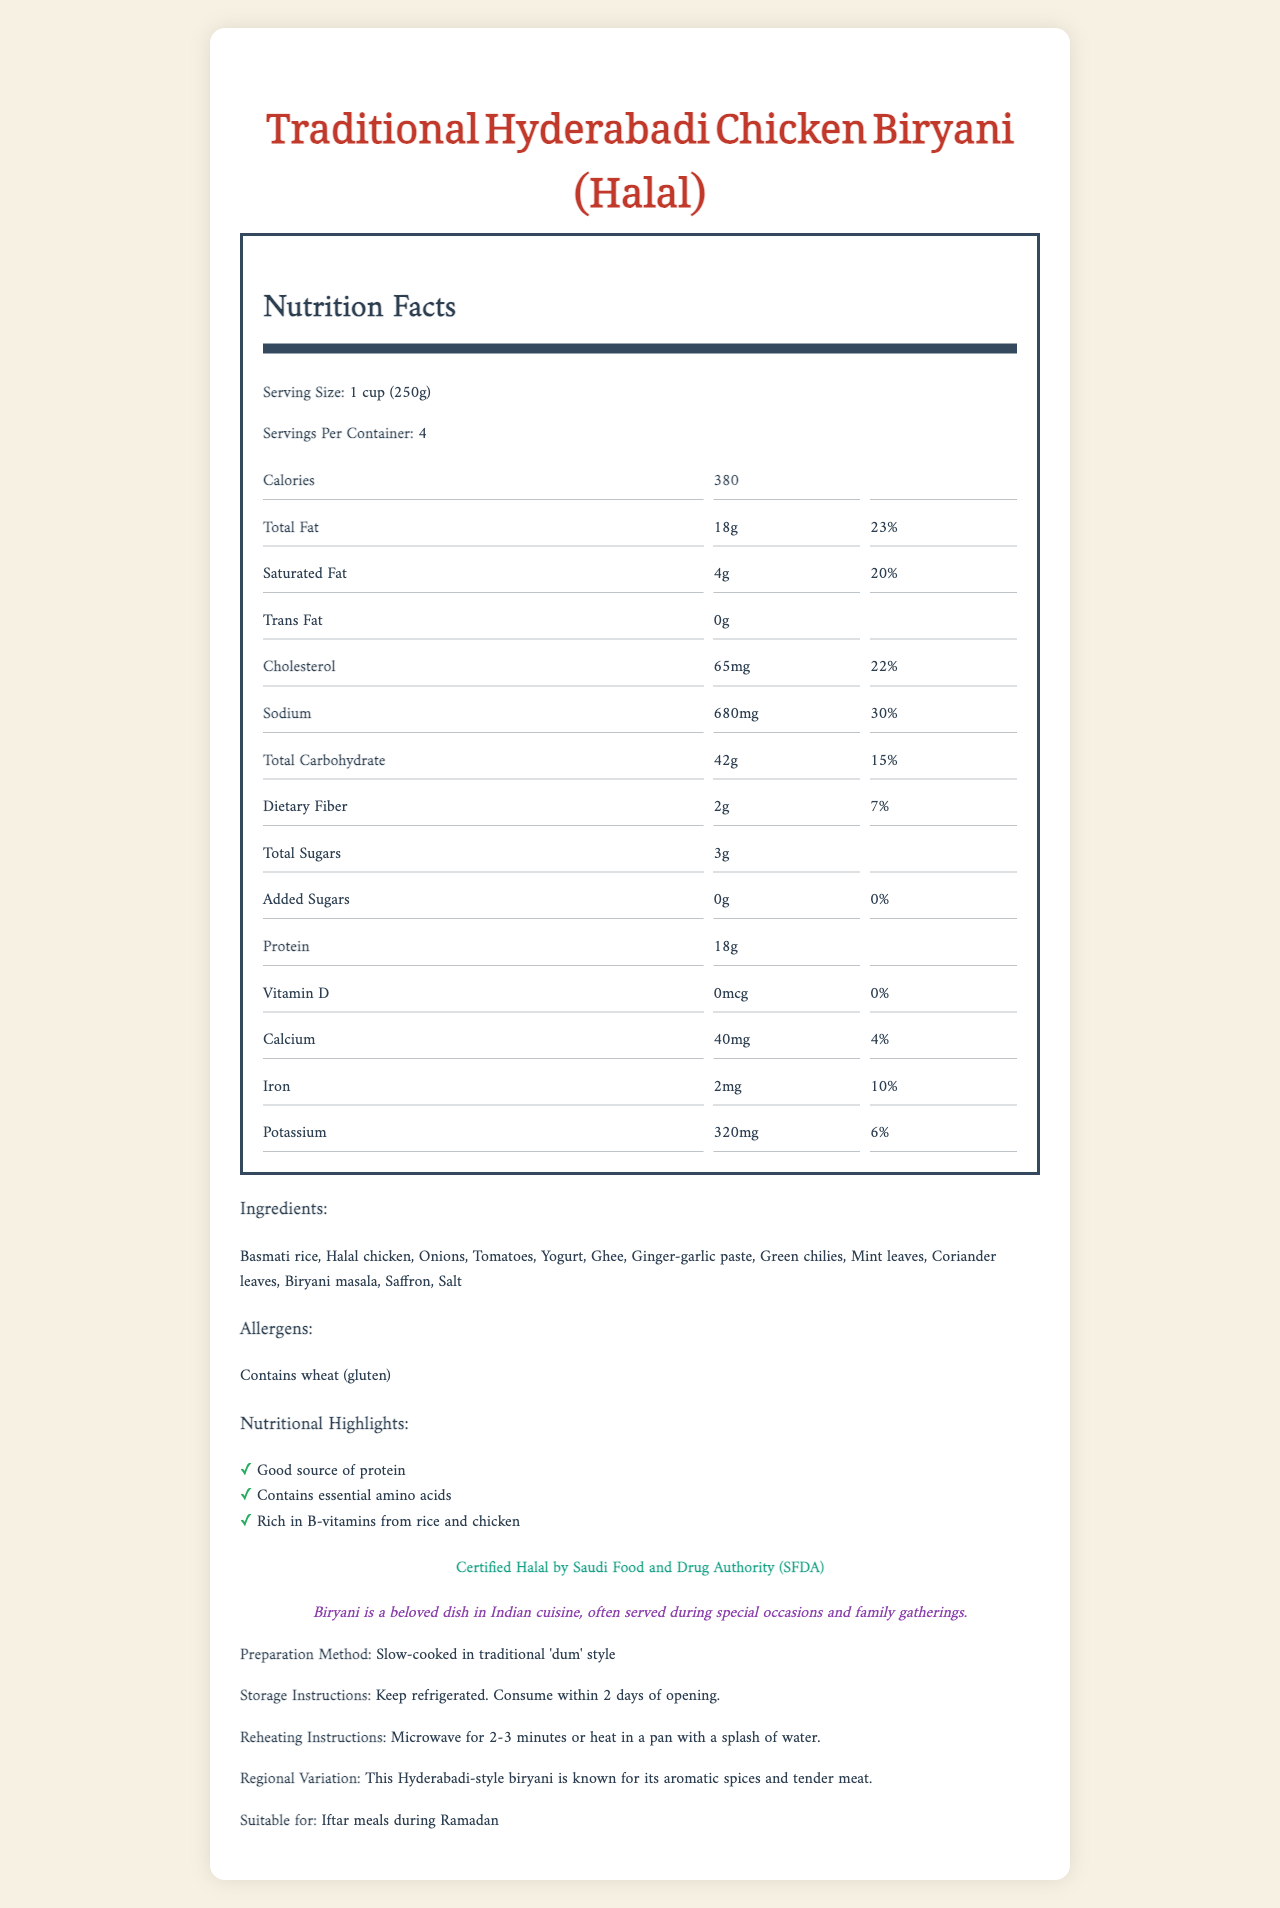what is the serving size? The document clearly states the serving size as "1 cup (250g)" right at the beginning under the Nutrition Facts section.
Answer: 1 cup (250g) how many servings are in a container? The document mentions "Servings Per Container: 4" which indicates that each container holds four servings.
Answer: 4 what is the calorie count per serving? The document lists the calorie count per serving under the Nutrition Facts section and states "Calories 380".
Answer: 380 how much total fat is in one serving? Under the Nutrition Facts, the Total Fat amount per serving is listed as "18g".
Answer: 18g what is the daily value percentage for sodium? The percentage daily value for Sodium is listed as "30%" under the Nutrition Facts section.
Answer: 30% what are the allergens listed in the document? The document lists "Contains wheat (gluten)" under the Allergens section.
Answer: Contains wheat (gluten) which certification does the product hold? The document states that the product is "Certified Halal by Saudi Food and Drug Authority (SFDA)".
Answer: Certified Halal by Saudi Food and Drug Authority (SFDA) what is the preparation method of the biryani? The preparation method is detailed as "Slow-cooked in traditional 'dum' style" in the document.
Answer: Slow-cooked in traditional 'dum' style what is the protein amount per serving? According to the Nutrition Facts section, Protein amount per serving is 18g.
Answer: 18g how should the biryani be reheated? The document provides reheating instructions as "Microwave for 2-3 minutes or heat in a pan with a splash of water."
Answer: Microwave for 2-3 minutes or heat in a pan with a splash of water which of the following is true about the carbohydrates in this product A. Total Carbohydrate is 50g B. Dietary Fiber is 4g C. Total Sugars is 3g D. Added Sugars is 5g The Nutrition Facts section states that Total Sugars is 3g, making option C correct.
Answer: C what are some of the listed ingredients in the biryani? A. Halal chicken B. White rice C. Saffron D. Tomatoes E. Pepper The ingredients listed in the document include Halal chicken, Saffron, and Tomatoes, which makes options A, C, and D correct.
Answer: A, C, D is this biryani product suitable for Iftar meals during Ramadan? The document explicitly mentions that it is "Suitable for Iftar meals during Ramadan."
Answer: Yes summarize the main idea and the key aspects of the document. The document is centered on providing detailed nutritional information and preparation guidelines for Traditional Hyderabadi Chicken Biryani, highlighting its halal certification and suitability for cultural occasions.
Answer: This document provides the Nutrition Facts for Traditional Hyderabadi Chicken Biryani made with halal meat, including serving size, calorie content, and nutritional information. It lists the ingredients used, preparation method, and storage instructions. The product is certified halal by the SFDA and is suitable for special occasions, including Iftar meals during Ramadan. how does this product contribute to the daily nutritional needs, based on its nutritional highlights? The nutritional highlights state that this biryani is a good source of protein, contains essential amino acids, and is rich in B-vitamins, contributing significantly to daily nutritional needs.
Answer: Good source of protein, contains essential amino acids, and is rich in B-vitamins from rice and chicken. what is the main source of iron in this product? The document does not specify the source of iron within the ingredients.
Answer: Cannot be determined 